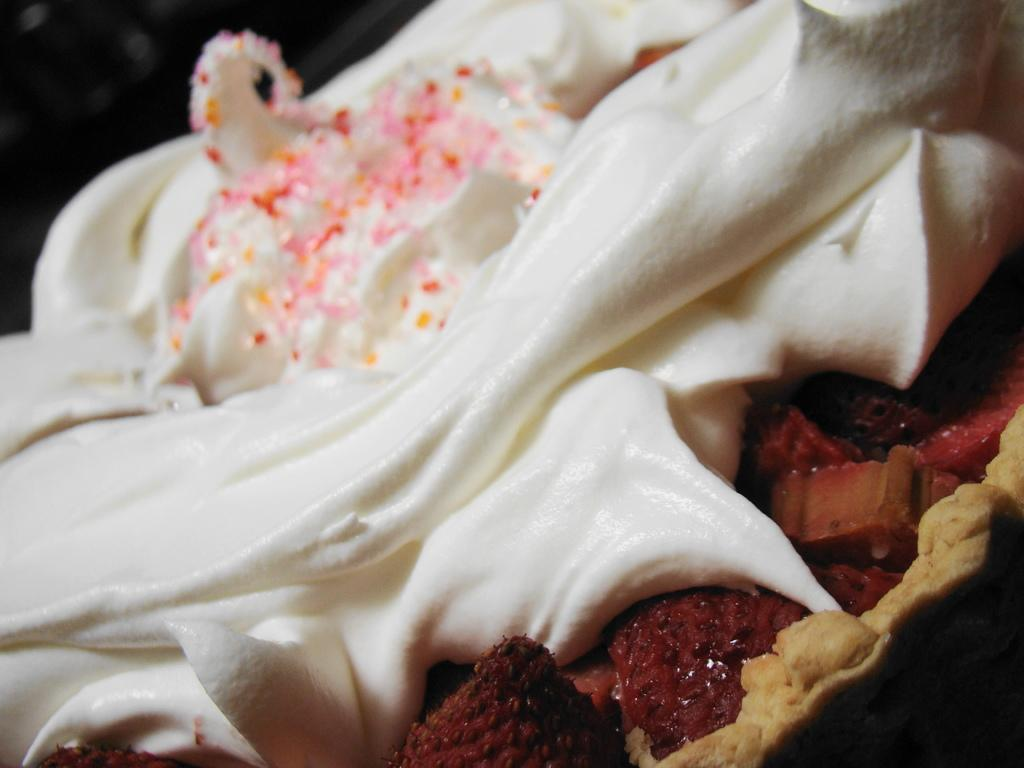What color is the food in the image? The food in the image is brown-colored. What is covering the brown-colored food? There is white-colored cream on the food. What color are the ingredients on top of the cream? The ingredients on top of the cream are pink-colored. What type of linen can be seen draped over the food in the image? There is no linen present in the image; it is a dish with brown food, white cream, and pink ingredients. What is the moon's position in the image? The moon is not visible in the image; it is a close-up of a dish with brown food, white cream, and pink ingredients. 